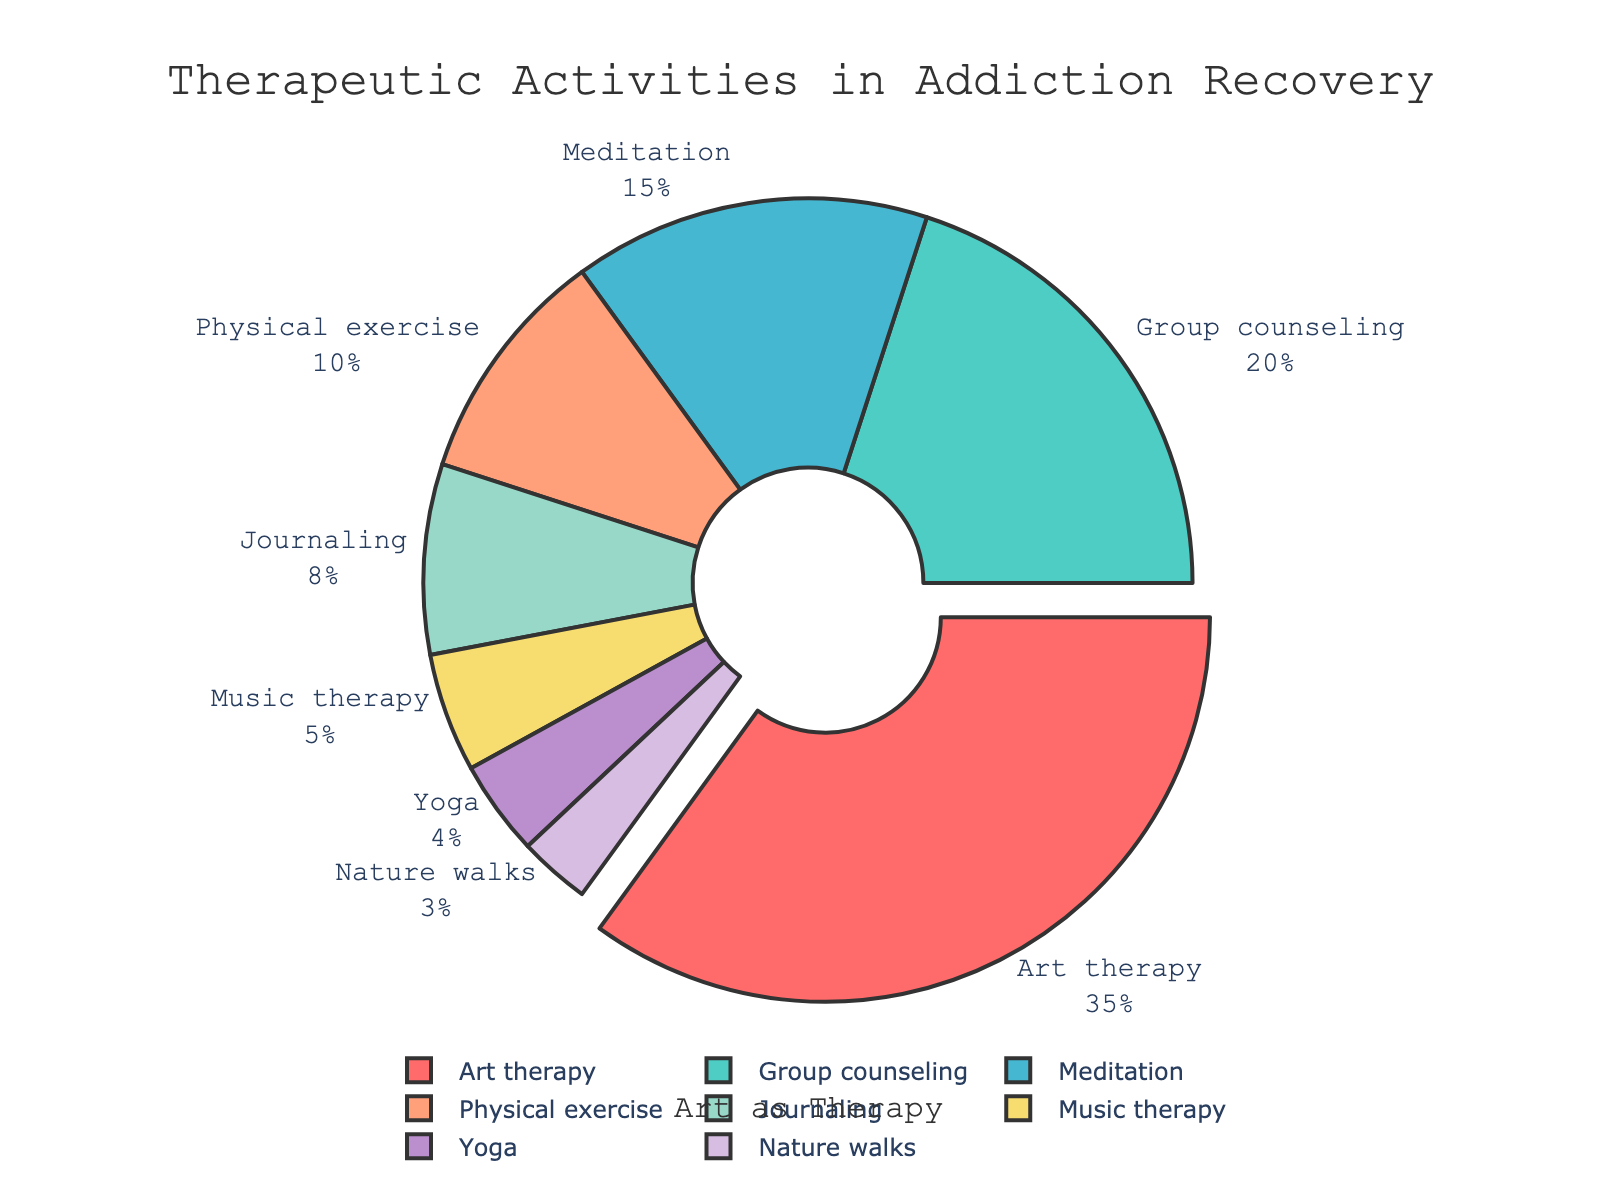What activity is the most engaged in during addiction recovery? The segment labeled "Art therapy" is the largest, occupying 35% of the pie chart, indicating it is the most engaged activity.
Answer: Art therapy Which activity has the smallest proportion in the pie chart? The segment labeled "Nature walks" is the smallest, with 3% of the total percentage.
Answer: Nature walks How much more common is Art therapy compared to Yoga? Art therapy constitutes 35% and Yoga constitutes 4%. The difference is 35% - 4% = 31%.
Answer: 31% What is the combined percentage of Group counseling and Meditation? Group counseling is 20% and Meditation is 15%. Combined, they add up to 20% + 15% = 35%.
Answer: 35% Which activities together make up less than 10% of the total therapeutic activities? Yoga at 4%, Nature walks at 3%, Music therapy at 5%, and Journaling at 8%. Only Yoga and Nature walks combined total 4% + 3% = 7%, which is less than 10%.
Answer: Yoga and Nature walks Compare the engagement in Physical exercise vs. Music therapy. Which one has a higher percentage? Physical exercise has 10% while Music therapy has 5%; Physical exercise is higher.
Answer: Physical exercise What proportion of the pie chart is taken up by activities related to physical well-being (Physical exercise, Yoga, Nature walks)? Physical exercise (10%) + Yoga (4%) + Nature walks (3%) = 17%.
Answer: 17% If one wanted to equally distribute the percentage of Art therapy among Music therapy, Yoga, and Nature walks, what would each get? Art therapy is 35%. The total of Music therapy, Yoga, and Nature walks is currently 5% + 4% + 3% = 12%. Adding 35% to 12% gives 47%. Dividing by 3 (activities): 47% / 3 ≈ 15.67% for each.
Answer: 15.67% Which activities combined amount to half of the total percentage of therapeutic activities? The combined percentage of Art therapy (35%) and Group counseling (20%) is 35% + 20% = 55%, which is more than half. Art therapy (35%) with Meditation (15%) amounts to 50%.
Answer: Art therapy and Meditation 